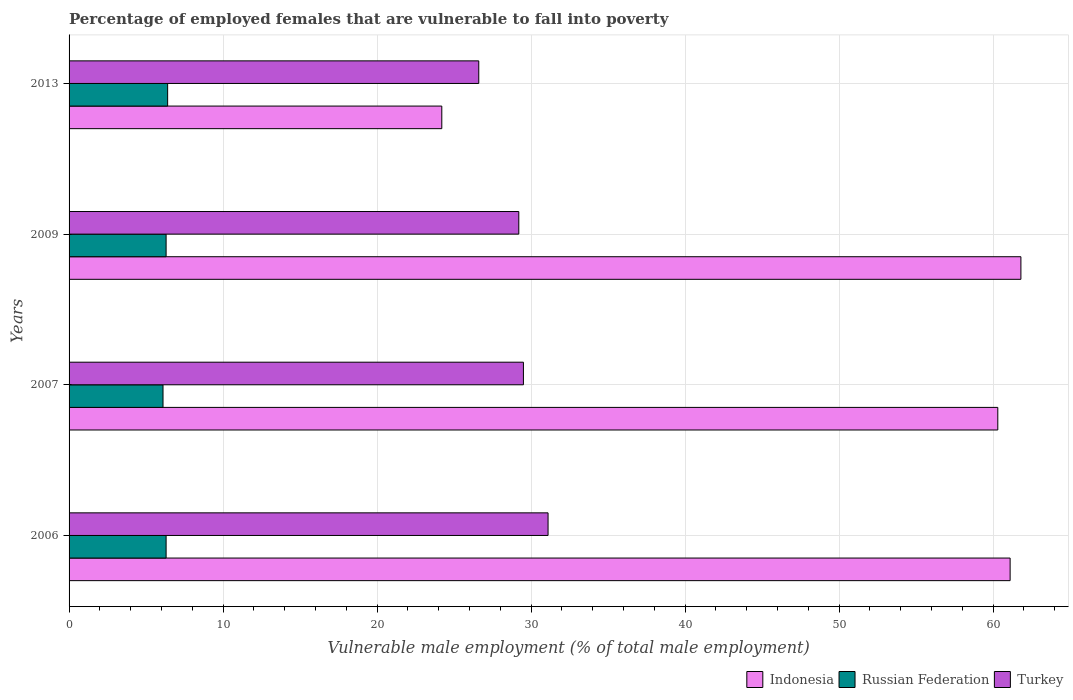How many different coloured bars are there?
Offer a terse response. 3. Are the number of bars on each tick of the Y-axis equal?
Keep it short and to the point. Yes. How many bars are there on the 3rd tick from the bottom?
Offer a very short reply. 3. What is the label of the 2nd group of bars from the top?
Ensure brevity in your answer.  2009. In how many cases, is the number of bars for a given year not equal to the number of legend labels?
Your answer should be very brief. 0. What is the percentage of employed females who are vulnerable to fall into poverty in Turkey in 2007?
Provide a short and direct response. 29.5. Across all years, what is the maximum percentage of employed females who are vulnerable to fall into poverty in Indonesia?
Keep it short and to the point. 61.8. Across all years, what is the minimum percentage of employed females who are vulnerable to fall into poverty in Russian Federation?
Ensure brevity in your answer.  6.1. In which year was the percentage of employed females who are vulnerable to fall into poverty in Russian Federation minimum?
Provide a short and direct response. 2007. What is the total percentage of employed females who are vulnerable to fall into poverty in Indonesia in the graph?
Provide a short and direct response. 207.4. What is the difference between the percentage of employed females who are vulnerable to fall into poverty in Indonesia in 2007 and that in 2009?
Offer a terse response. -1.5. What is the difference between the percentage of employed females who are vulnerable to fall into poverty in Russian Federation in 2009 and the percentage of employed females who are vulnerable to fall into poverty in Turkey in 2007?
Your answer should be compact. -23.2. What is the average percentage of employed females who are vulnerable to fall into poverty in Turkey per year?
Keep it short and to the point. 29.1. In the year 2013, what is the difference between the percentage of employed females who are vulnerable to fall into poverty in Russian Federation and percentage of employed females who are vulnerable to fall into poverty in Indonesia?
Ensure brevity in your answer.  -17.8. In how many years, is the percentage of employed females who are vulnerable to fall into poverty in Indonesia greater than 16 %?
Your answer should be compact. 4. What is the ratio of the percentage of employed females who are vulnerable to fall into poverty in Indonesia in 2007 to that in 2009?
Ensure brevity in your answer.  0.98. Is the difference between the percentage of employed females who are vulnerable to fall into poverty in Russian Federation in 2006 and 2013 greater than the difference between the percentage of employed females who are vulnerable to fall into poverty in Indonesia in 2006 and 2013?
Keep it short and to the point. No. What is the difference between the highest and the second highest percentage of employed females who are vulnerable to fall into poverty in Turkey?
Make the answer very short. 1.6. What is the difference between the highest and the lowest percentage of employed females who are vulnerable to fall into poverty in Russian Federation?
Your answer should be very brief. 0.3. In how many years, is the percentage of employed females who are vulnerable to fall into poverty in Russian Federation greater than the average percentage of employed females who are vulnerable to fall into poverty in Russian Federation taken over all years?
Ensure brevity in your answer.  3. What does the 3rd bar from the bottom in 2013 represents?
Make the answer very short. Turkey. How many bars are there?
Your answer should be compact. 12. Where does the legend appear in the graph?
Give a very brief answer. Bottom right. What is the title of the graph?
Offer a very short reply. Percentage of employed females that are vulnerable to fall into poverty. Does "Zambia" appear as one of the legend labels in the graph?
Your answer should be compact. No. What is the label or title of the X-axis?
Provide a succinct answer. Vulnerable male employment (% of total male employment). What is the Vulnerable male employment (% of total male employment) in Indonesia in 2006?
Your answer should be compact. 61.1. What is the Vulnerable male employment (% of total male employment) in Russian Federation in 2006?
Give a very brief answer. 6.3. What is the Vulnerable male employment (% of total male employment) of Turkey in 2006?
Give a very brief answer. 31.1. What is the Vulnerable male employment (% of total male employment) of Indonesia in 2007?
Your answer should be very brief. 60.3. What is the Vulnerable male employment (% of total male employment) of Russian Federation in 2007?
Provide a short and direct response. 6.1. What is the Vulnerable male employment (% of total male employment) in Turkey in 2007?
Provide a short and direct response. 29.5. What is the Vulnerable male employment (% of total male employment) of Indonesia in 2009?
Offer a very short reply. 61.8. What is the Vulnerable male employment (% of total male employment) in Russian Federation in 2009?
Ensure brevity in your answer.  6.3. What is the Vulnerable male employment (% of total male employment) in Turkey in 2009?
Your answer should be compact. 29.2. What is the Vulnerable male employment (% of total male employment) of Indonesia in 2013?
Your response must be concise. 24.2. What is the Vulnerable male employment (% of total male employment) in Russian Federation in 2013?
Give a very brief answer. 6.4. What is the Vulnerable male employment (% of total male employment) in Turkey in 2013?
Provide a short and direct response. 26.6. Across all years, what is the maximum Vulnerable male employment (% of total male employment) in Indonesia?
Ensure brevity in your answer.  61.8. Across all years, what is the maximum Vulnerable male employment (% of total male employment) in Russian Federation?
Provide a succinct answer. 6.4. Across all years, what is the maximum Vulnerable male employment (% of total male employment) of Turkey?
Keep it short and to the point. 31.1. Across all years, what is the minimum Vulnerable male employment (% of total male employment) of Indonesia?
Offer a terse response. 24.2. Across all years, what is the minimum Vulnerable male employment (% of total male employment) of Russian Federation?
Provide a short and direct response. 6.1. Across all years, what is the minimum Vulnerable male employment (% of total male employment) of Turkey?
Your answer should be very brief. 26.6. What is the total Vulnerable male employment (% of total male employment) in Indonesia in the graph?
Your answer should be very brief. 207.4. What is the total Vulnerable male employment (% of total male employment) of Russian Federation in the graph?
Your answer should be very brief. 25.1. What is the total Vulnerable male employment (% of total male employment) of Turkey in the graph?
Ensure brevity in your answer.  116.4. What is the difference between the Vulnerable male employment (% of total male employment) of Indonesia in 2006 and that in 2013?
Your answer should be compact. 36.9. What is the difference between the Vulnerable male employment (% of total male employment) in Russian Federation in 2006 and that in 2013?
Your response must be concise. -0.1. What is the difference between the Vulnerable male employment (% of total male employment) of Turkey in 2006 and that in 2013?
Provide a succinct answer. 4.5. What is the difference between the Vulnerable male employment (% of total male employment) in Indonesia in 2007 and that in 2009?
Your answer should be compact. -1.5. What is the difference between the Vulnerable male employment (% of total male employment) of Turkey in 2007 and that in 2009?
Offer a very short reply. 0.3. What is the difference between the Vulnerable male employment (% of total male employment) of Indonesia in 2007 and that in 2013?
Keep it short and to the point. 36.1. What is the difference between the Vulnerable male employment (% of total male employment) in Russian Federation in 2007 and that in 2013?
Offer a terse response. -0.3. What is the difference between the Vulnerable male employment (% of total male employment) of Indonesia in 2009 and that in 2013?
Keep it short and to the point. 37.6. What is the difference between the Vulnerable male employment (% of total male employment) in Russian Federation in 2009 and that in 2013?
Ensure brevity in your answer.  -0.1. What is the difference between the Vulnerable male employment (% of total male employment) in Indonesia in 2006 and the Vulnerable male employment (% of total male employment) in Russian Federation in 2007?
Your answer should be very brief. 55. What is the difference between the Vulnerable male employment (% of total male employment) in Indonesia in 2006 and the Vulnerable male employment (% of total male employment) in Turkey in 2007?
Your response must be concise. 31.6. What is the difference between the Vulnerable male employment (% of total male employment) of Russian Federation in 2006 and the Vulnerable male employment (% of total male employment) of Turkey in 2007?
Make the answer very short. -23.2. What is the difference between the Vulnerable male employment (% of total male employment) in Indonesia in 2006 and the Vulnerable male employment (% of total male employment) in Russian Federation in 2009?
Ensure brevity in your answer.  54.8. What is the difference between the Vulnerable male employment (% of total male employment) in Indonesia in 2006 and the Vulnerable male employment (% of total male employment) in Turkey in 2009?
Your answer should be compact. 31.9. What is the difference between the Vulnerable male employment (% of total male employment) in Russian Federation in 2006 and the Vulnerable male employment (% of total male employment) in Turkey in 2009?
Give a very brief answer. -22.9. What is the difference between the Vulnerable male employment (% of total male employment) of Indonesia in 2006 and the Vulnerable male employment (% of total male employment) of Russian Federation in 2013?
Your answer should be very brief. 54.7. What is the difference between the Vulnerable male employment (% of total male employment) in Indonesia in 2006 and the Vulnerable male employment (% of total male employment) in Turkey in 2013?
Keep it short and to the point. 34.5. What is the difference between the Vulnerable male employment (% of total male employment) of Russian Federation in 2006 and the Vulnerable male employment (% of total male employment) of Turkey in 2013?
Give a very brief answer. -20.3. What is the difference between the Vulnerable male employment (% of total male employment) of Indonesia in 2007 and the Vulnerable male employment (% of total male employment) of Turkey in 2009?
Your answer should be very brief. 31.1. What is the difference between the Vulnerable male employment (% of total male employment) in Russian Federation in 2007 and the Vulnerable male employment (% of total male employment) in Turkey in 2009?
Your response must be concise. -23.1. What is the difference between the Vulnerable male employment (% of total male employment) of Indonesia in 2007 and the Vulnerable male employment (% of total male employment) of Russian Federation in 2013?
Make the answer very short. 53.9. What is the difference between the Vulnerable male employment (% of total male employment) of Indonesia in 2007 and the Vulnerable male employment (% of total male employment) of Turkey in 2013?
Provide a succinct answer. 33.7. What is the difference between the Vulnerable male employment (% of total male employment) in Russian Federation in 2007 and the Vulnerable male employment (% of total male employment) in Turkey in 2013?
Your answer should be compact. -20.5. What is the difference between the Vulnerable male employment (% of total male employment) in Indonesia in 2009 and the Vulnerable male employment (% of total male employment) in Russian Federation in 2013?
Provide a succinct answer. 55.4. What is the difference between the Vulnerable male employment (% of total male employment) of Indonesia in 2009 and the Vulnerable male employment (% of total male employment) of Turkey in 2013?
Your answer should be compact. 35.2. What is the difference between the Vulnerable male employment (% of total male employment) in Russian Federation in 2009 and the Vulnerable male employment (% of total male employment) in Turkey in 2013?
Offer a terse response. -20.3. What is the average Vulnerable male employment (% of total male employment) in Indonesia per year?
Offer a terse response. 51.85. What is the average Vulnerable male employment (% of total male employment) in Russian Federation per year?
Offer a terse response. 6.28. What is the average Vulnerable male employment (% of total male employment) of Turkey per year?
Make the answer very short. 29.1. In the year 2006, what is the difference between the Vulnerable male employment (% of total male employment) of Indonesia and Vulnerable male employment (% of total male employment) of Russian Federation?
Your answer should be compact. 54.8. In the year 2006, what is the difference between the Vulnerable male employment (% of total male employment) of Indonesia and Vulnerable male employment (% of total male employment) of Turkey?
Your answer should be very brief. 30. In the year 2006, what is the difference between the Vulnerable male employment (% of total male employment) of Russian Federation and Vulnerable male employment (% of total male employment) of Turkey?
Offer a terse response. -24.8. In the year 2007, what is the difference between the Vulnerable male employment (% of total male employment) in Indonesia and Vulnerable male employment (% of total male employment) in Russian Federation?
Offer a terse response. 54.2. In the year 2007, what is the difference between the Vulnerable male employment (% of total male employment) of Indonesia and Vulnerable male employment (% of total male employment) of Turkey?
Offer a very short reply. 30.8. In the year 2007, what is the difference between the Vulnerable male employment (% of total male employment) in Russian Federation and Vulnerable male employment (% of total male employment) in Turkey?
Your answer should be compact. -23.4. In the year 2009, what is the difference between the Vulnerable male employment (% of total male employment) of Indonesia and Vulnerable male employment (% of total male employment) of Russian Federation?
Provide a succinct answer. 55.5. In the year 2009, what is the difference between the Vulnerable male employment (% of total male employment) of Indonesia and Vulnerable male employment (% of total male employment) of Turkey?
Provide a succinct answer. 32.6. In the year 2009, what is the difference between the Vulnerable male employment (% of total male employment) of Russian Federation and Vulnerable male employment (% of total male employment) of Turkey?
Your answer should be very brief. -22.9. In the year 2013, what is the difference between the Vulnerable male employment (% of total male employment) in Indonesia and Vulnerable male employment (% of total male employment) in Turkey?
Your answer should be very brief. -2.4. In the year 2013, what is the difference between the Vulnerable male employment (% of total male employment) of Russian Federation and Vulnerable male employment (% of total male employment) of Turkey?
Provide a succinct answer. -20.2. What is the ratio of the Vulnerable male employment (% of total male employment) of Indonesia in 2006 to that in 2007?
Your answer should be compact. 1.01. What is the ratio of the Vulnerable male employment (% of total male employment) of Russian Federation in 2006 to that in 2007?
Your answer should be compact. 1.03. What is the ratio of the Vulnerable male employment (% of total male employment) in Turkey in 2006 to that in 2007?
Provide a succinct answer. 1.05. What is the ratio of the Vulnerable male employment (% of total male employment) in Indonesia in 2006 to that in 2009?
Your answer should be very brief. 0.99. What is the ratio of the Vulnerable male employment (% of total male employment) in Turkey in 2006 to that in 2009?
Make the answer very short. 1.07. What is the ratio of the Vulnerable male employment (% of total male employment) of Indonesia in 2006 to that in 2013?
Make the answer very short. 2.52. What is the ratio of the Vulnerable male employment (% of total male employment) in Russian Federation in 2006 to that in 2013?
Give a very brief answer. 0.98. What is the ratio of the Vulnerable male employment (% of total male employment) in Turkey in 2006 to that in 2013?
Your answer should be compact. 1.17. What is the ratio of the Vulnerable male employment (% of total male employment) in Indonesia in 2007 to that in 2009?
Offer a terse response. 0.98. What is the ratio of the Vulnerable male employment (% of total male employment) in Russian Federation in 2007 to that in 2009?
Make the answer very short. 0.97. What is the ratio of the Vulnerable male employment (% of total male employment) in Turkey in 2007 to that in 2009?
Keep it short and to the point. 1.01. What is the ratio of the Vulnerable male employment (% of total male employment) in Indonesia in 2007 to that in 2013?
Offer a terse response. 2.49. What is the ratio of the Vulnerable male employment (% of total male employment) of Russian Federation in 2007 to that in 2013?
Make the answer very short. 0.95. What is the ratio of the Vulnerable male employment (% of total male employment) in Turkey in 2007 to that in 2013?
Offer a terse response. 1.11. What is the ratio of the Vulnerable male employment (% of total male employment) of Indonesia in 2009 to that in 2013?
Provide a short and direct response. 2.55. What is the ratio of the Vulnerable male employment (% of total male employment) in Russian Federation in 2009 to that in 2013?
Offer a very short reply. 0.98. What is the ratio of the Vulnerable male employment (% of total male employment) in Turkey in 2009 to that in 2013?
Your answer should be compact. 1.1. What is the difference between the highest and the second highest Vulnerable male employment (% of total male employment) of Indonesia?
Offer a terse response. 0.7. What is the difference between the highest and the lowest Vulnerable male employment (% of total male employment) of Indonesia?
Ensure brevity in your answer.  37.6. What is the difference between the highest and the lowest Vulnerable male employment (% of total male employment) in Russian Federation?
Your answer should be compact. 0.3. What is the difference between the highest and the lowest Vulnerable male employment (% of total male employment) of Turkey?
Provide a short and direct response. 4.5. 